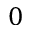Convert formula to latex. <formula><loc_0><loc_0><loc_500><loc_500>0</formula> 